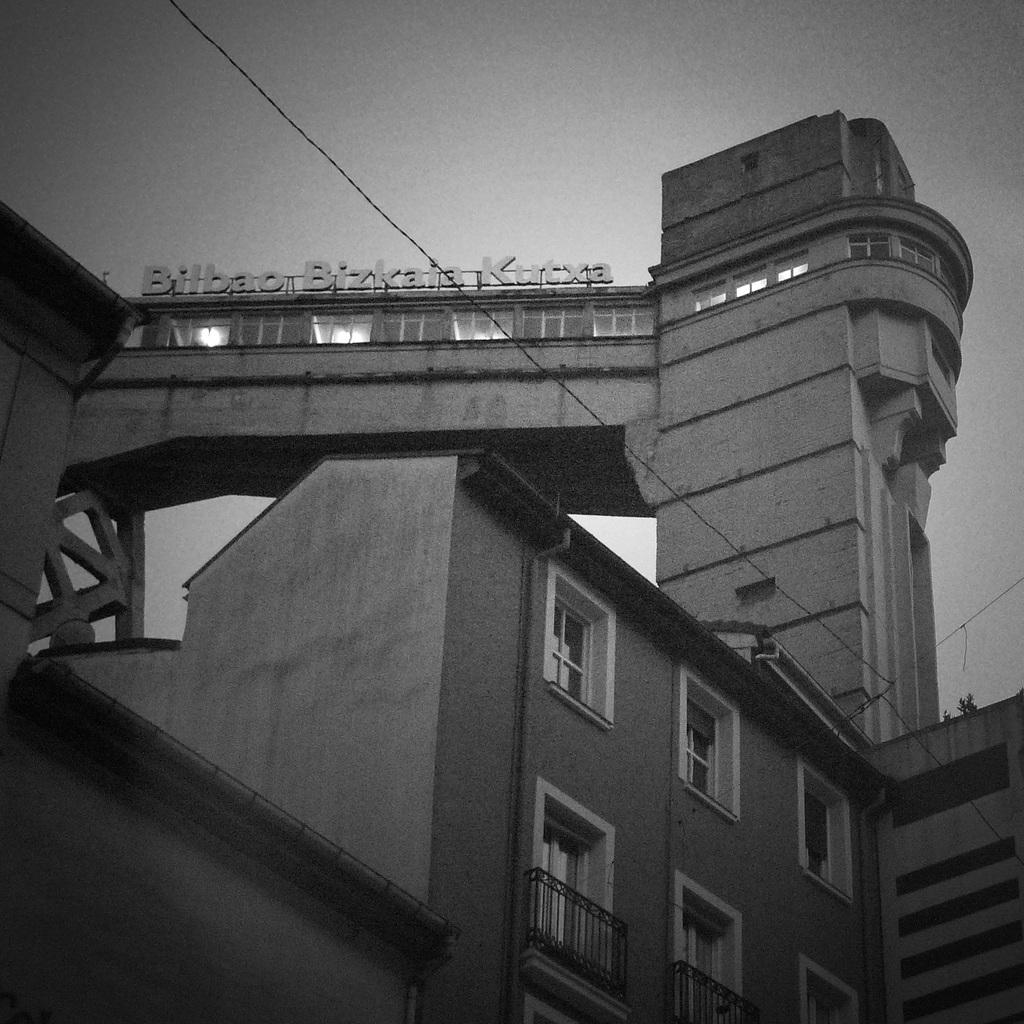What type of structures can be seen in the image? There are buildings in the image. What architectural features are present in the image? There are walls, windows, and railings in the image. What signage is visible in the image? There is a name board in the image. What type of material is present in the image? There is wire in the image. What can be seen in the background of the image? The sky is visible in the background of the image. What type of tray is being used for writing in the image? There is no tray or writing present in the image. What type of glass is visible in the image? There is no glass visible in the image. 